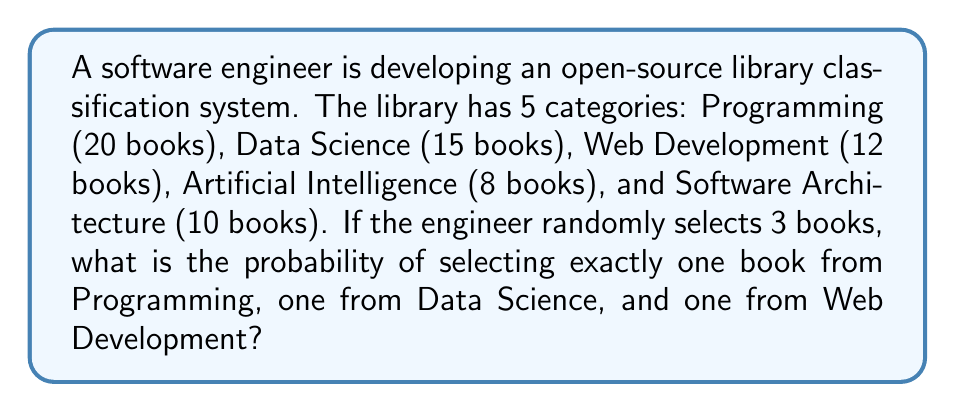Provide a solution to this math problem. To solve this problem, we'll use the concept of combinatorics and probability.

1. Calculate the total number of ways to select 3 books from the entire library:
   Total books = 20 + 15 + 12 + 8 + 10 = 65
   Total combinations = $\binom{65}{3}$

2. Calculate the number of ways to select one book from each specified category:
   Programming: $\binom{20}{1}$
   Data Science: $\binom{15}{1}$
   Web Development: $\binom{12}{1}$

3. Multiply these combinations to get the total number of favorable outcomes:
   Favorable outcomes = $\binom{20}{1} \cdot \binom{15}{1} \cdot \binom{12}{1}$

4. Calculate the probability by dividing favorable outcomes by total outcomes:

   $$P(\text{1 Programming, 1 Data Science, 1 Web Development}) = \frac{\binom{20}{1} \cdot \binom{15}{1} \cdot \binom{12}{1}}{\binom{65}{3}}$$

5. Simplify the calculation:
   $$P = \frac{20 \cdot 15 \cdot 12}{\frac{65 \cdot 64 \cdot 63}{3 \cdot 2 \cdot 1}}$$
   
   $$P = \frac{3600}{43680} = \frac{25}{304} \approx 0.0822$$
Answer: The probability of selecting exactly one book from Programming, one from Data Science, and one from Web Development is $\frac{25}{304}$ or approximately 0.0822 (8.22%). 